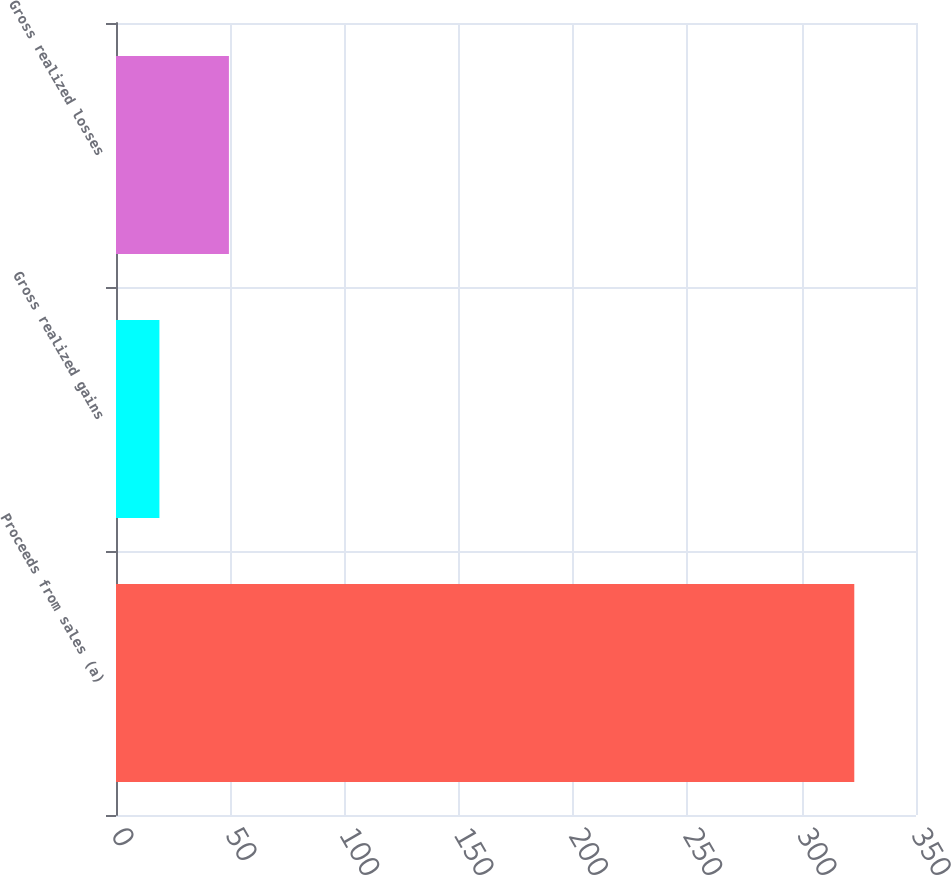<chart> <loc_0><loc_0><loc_500><loc_500><bar_chart><fcel>Proceeds from sales (a)<fcel>Gross realized gains<fcel>Gross realized losses<nl><fcel>323<fcel>19<fcel>49.4<nl></chart> 